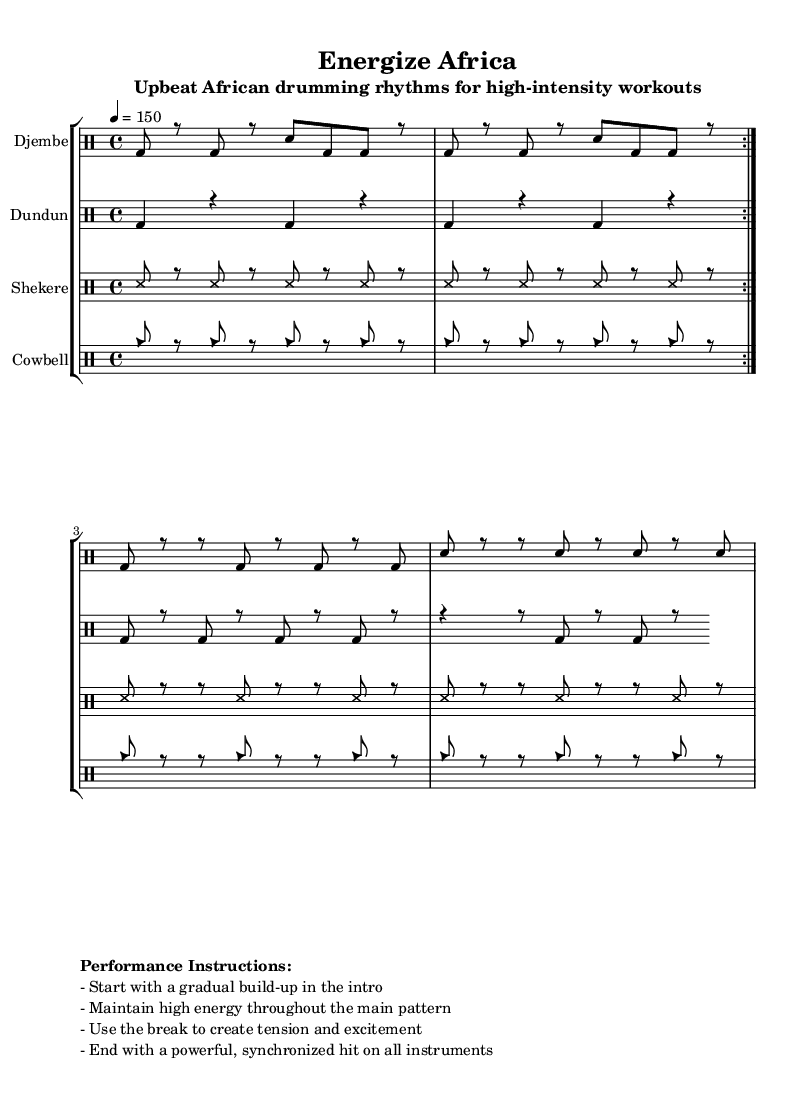What is the key signature of this music? The key signature is C major, which has no sharps or flats.
Answer: C major What is the time signature of this piece? The time signature is indicated as 4/4, meaning there are four beats in each measure and a quarter note receives one beat.
Answer: 4/4 What is the tempo marking for this piece? The tempo marking indicates a speed of 150 beats per minute, which is quite fast and suitable for high-energy workouts.
Answer: 150 How many main rhythmic patterns are there in this piece? There are four main rhythmic patterns indicated for different drum instruments: Djembe, Dundun, Shekere, and Cowbell.
Answer: Four Which instrument uses a rhythm pattern that includes 'ss'? The Shekere uses a rhythm pattern that features 'ss', which stands for slap sounds typical of this instrument.
Answer: Shekere What type of workout is this music specifically intended for? The music is designed for high-intensity workouts, which is reflected in its upbeat tempo and energetic rhythms.
Answer: High-intensity workouts What is the main purpose of the breaks in the rhythm patterns? The breaks in the rhythm patterns are intended to create tension and excitement before returning to the main pattern, enhancing the overall energy of the performance.
Answer: Create tension and excitement 